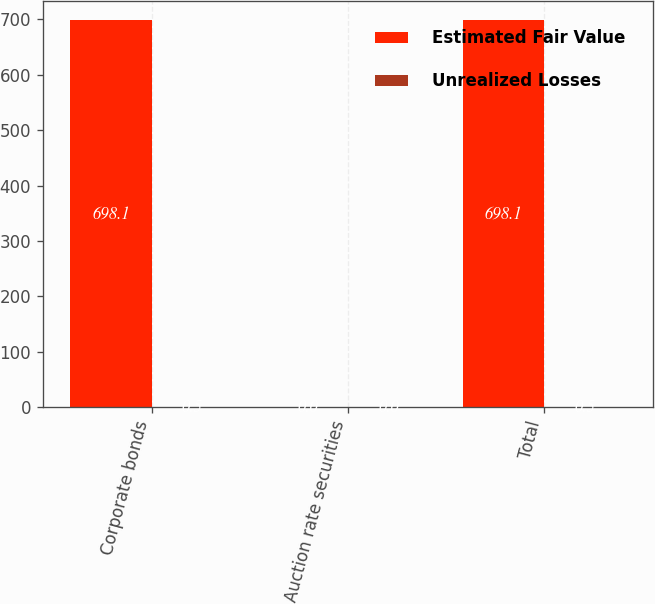Convert chart. <chart><loc_0><loc_0><loc_500><loc_500><stacked_bar_chart><ecel><fcel>Corporate bonds<fcel>Auction rate securities<fcel>Total<nl><fcel>Estimated Fair Value<fcel>698.1<fcel>0<fcel>698.1<nl><fcel>Unrealized Losses<fcel>0.5<fcel>0<fcel>0.5<nl></chart> 